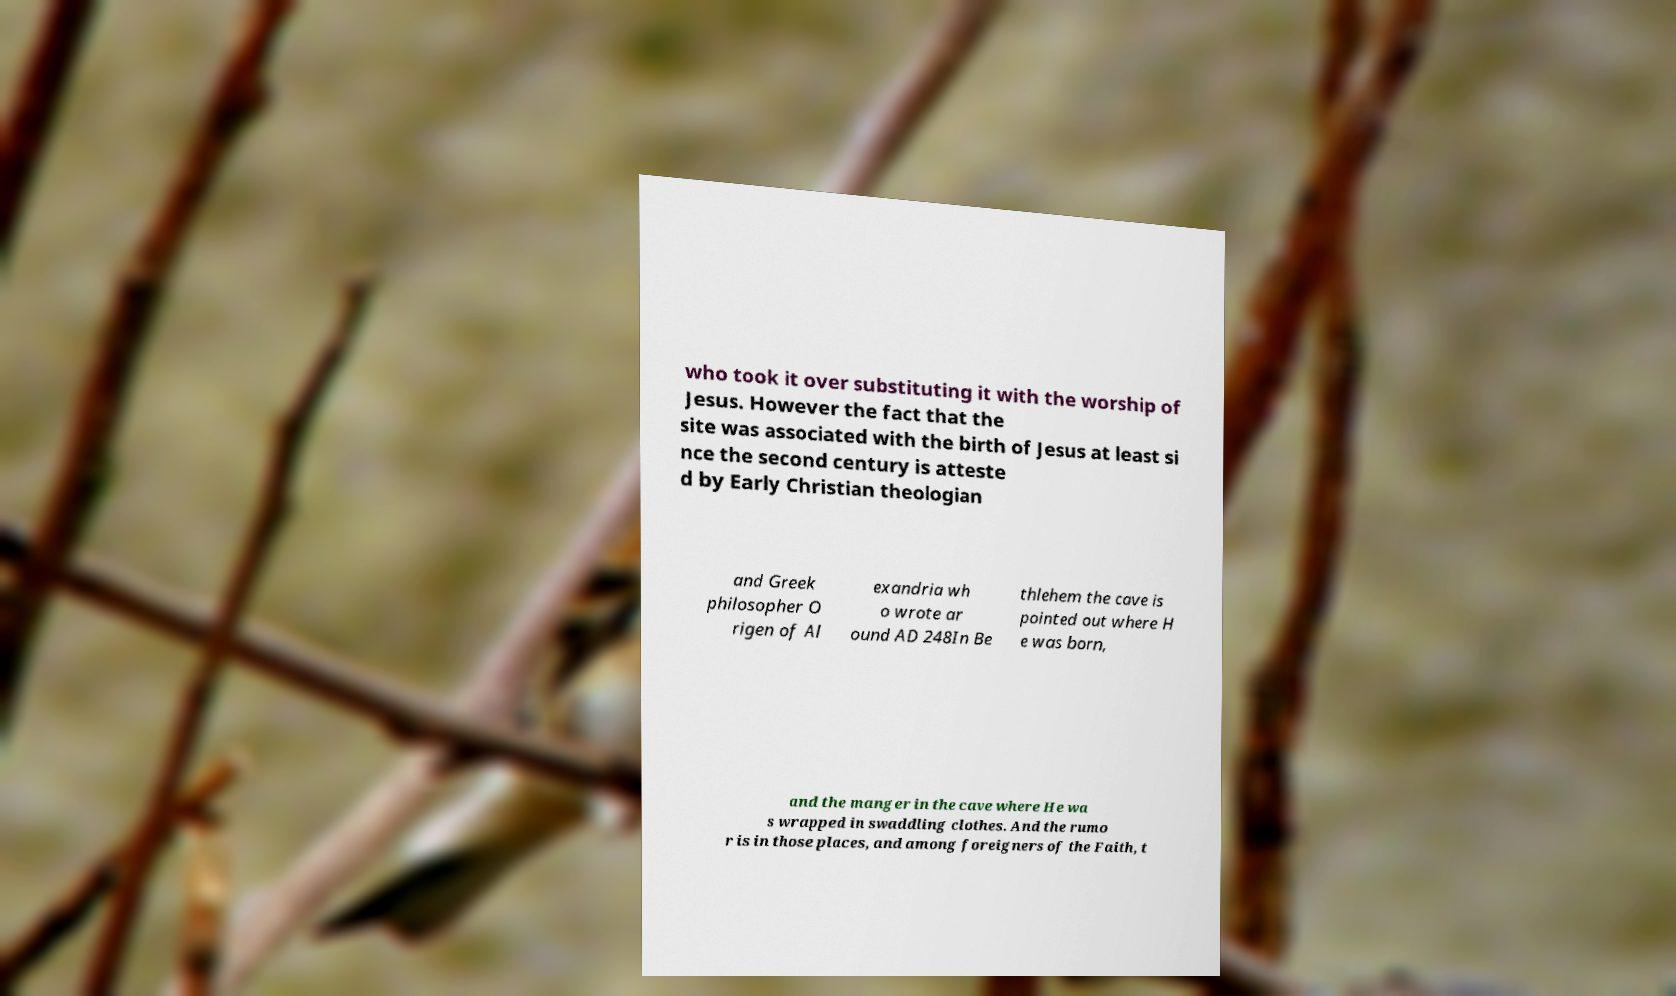Please identify and transcribe the text found in this image. who took it over substituting it with the worship of Jesus. However the fact that the site was associated with the birth of Jesus at least si nce the second century is atteste d by Early Christian theologian and Greek philosopher O rigen of Al exandria wh o wrote ar ound AD 248In Be thlehem the cave is pointed out where H e was born, and the manger in the cave where He wa s wrapped in swaddling clothes. And the rumo r is in those places, and among foreigners of the Faith, t 